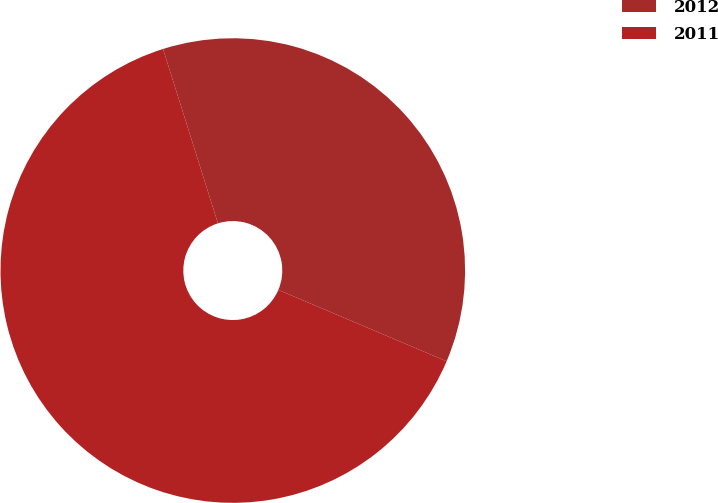Convert chart to OTSL. <chart><loc_0><loc_0><loc_500><loc_500><pie_chart><fcel>2012<fcel>2011<nl><fcel>36.24%<fcel>63.76%<nl></chart> 